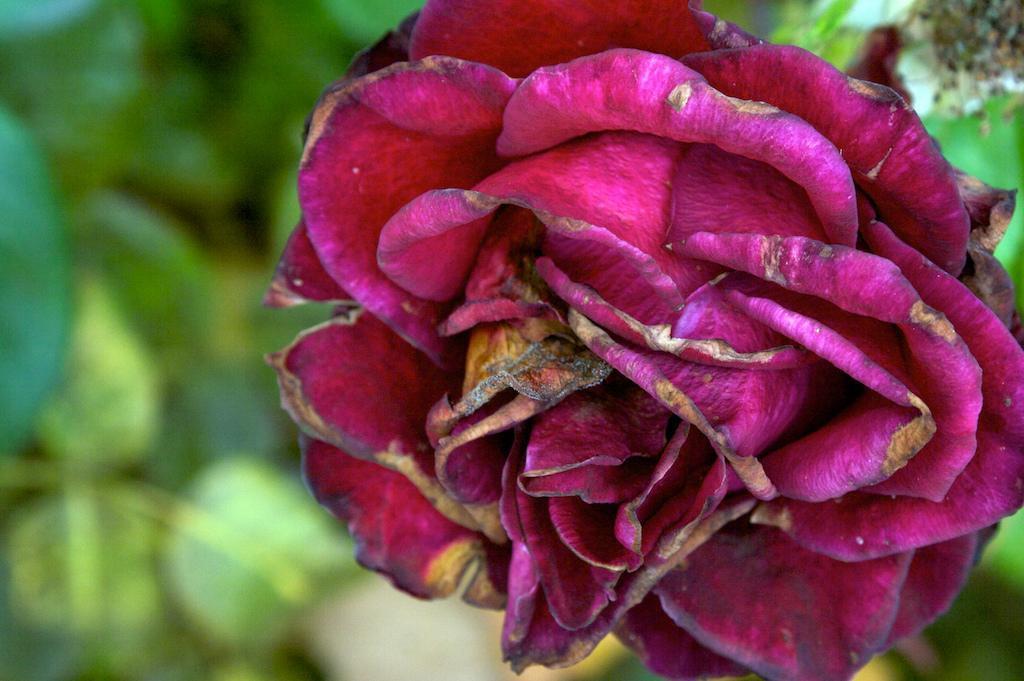In one or two sentences, can you explain what this image depicts? In this image I see a flower which is of pink in color and in the background I see the green leaves. 